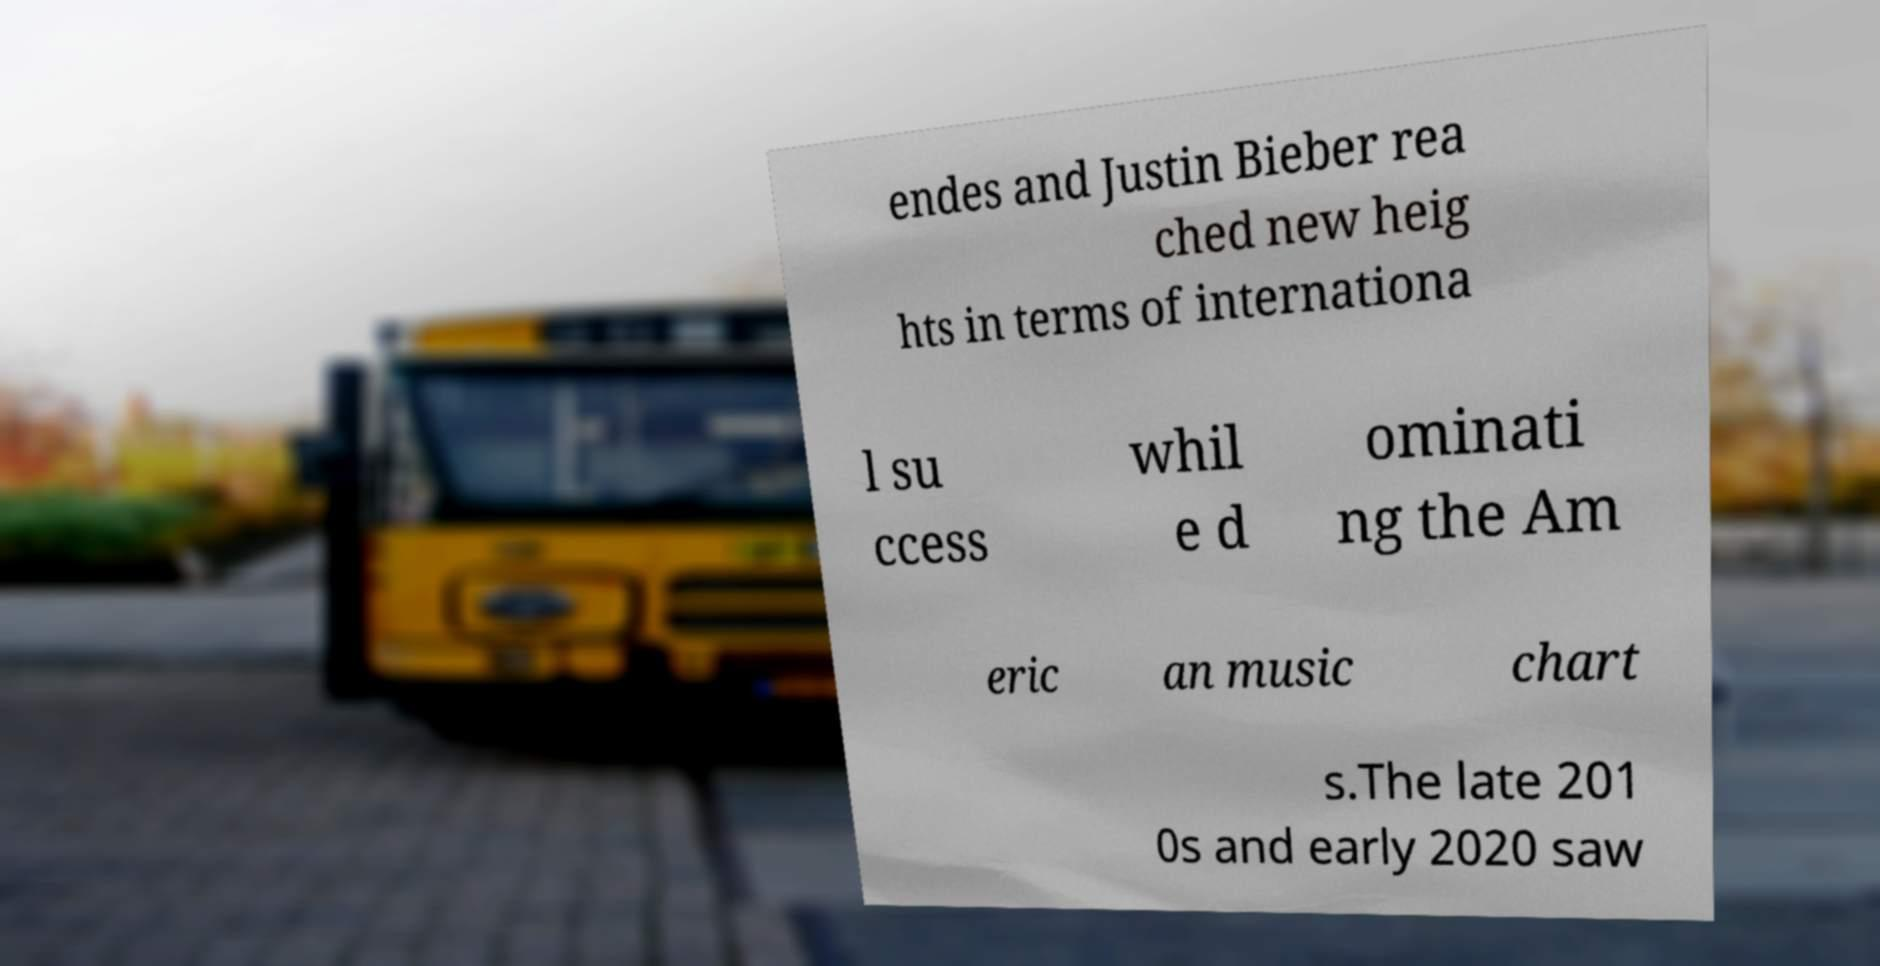Can you read and provide the text displayed in the image?This photo seems to have some interesting text. Can you extract and type it out for me? endes and Justin Bieber rea ched new heig hts in terms of internationa l su ccess whil e d ominati ng the Am eric an music chart s.The late 201 0s and early 2020 saw 